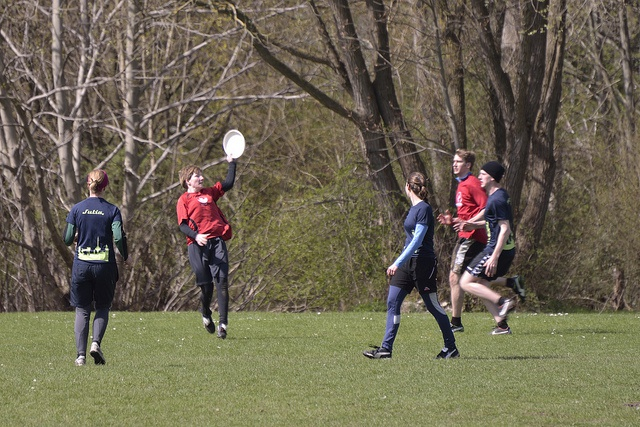Describe the objects in this image and their specific colors. I can see people in gray, black, and olive tones, people in gray, black, navy, and darkgray tones, people in gray, black, maroon, and salmon tones, people in gray, black, lightgray, and darkgray tones, and people in gray, black, salmon, and maroon tones in this image. 